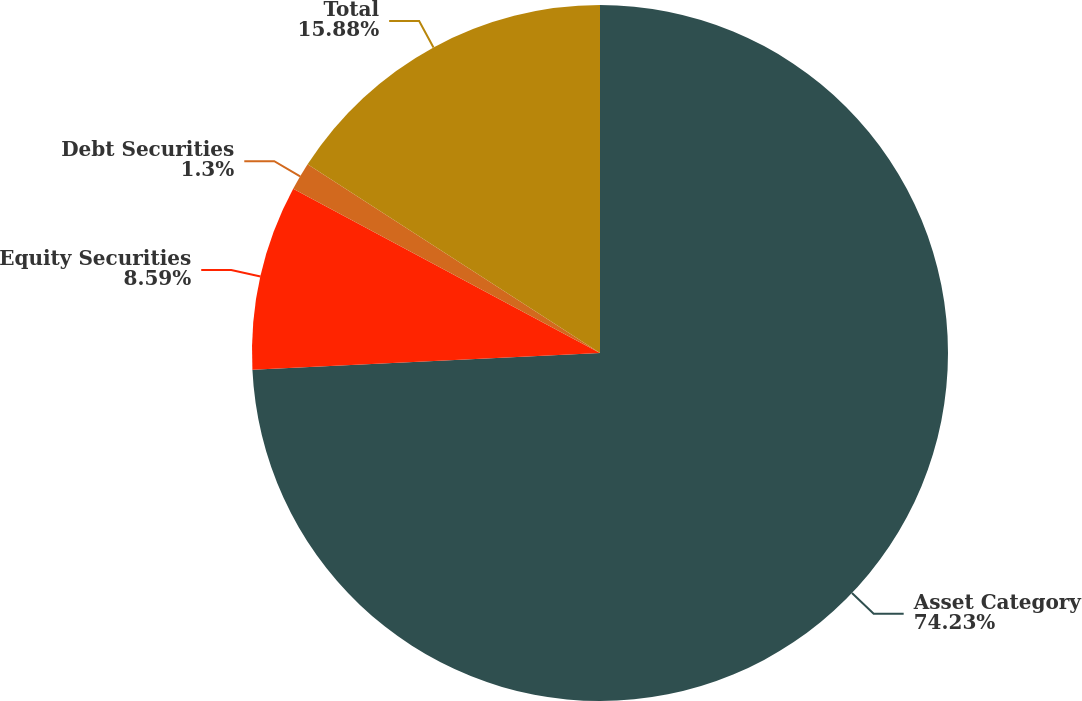<chart> <loc_0><loc_0><loc_500><loc_500><pie_chart><fcel>Asset Category<fcel>Equity Securities<fcel>Debt Securities<fcel>Total<nl><fcel>74.23%<fcel>8.59%<fcel>1.3%<fcel>15.88%<nl></chart> 